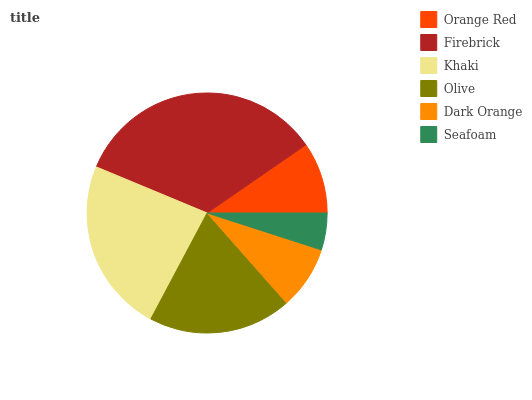Is Seafoam the minimum?
Answer yes or no. Yes. Is Firebrick the maximum?
Answer yes or no. Yes. Is Khaki the minimum?
Answer yes or no. No. Is Khaki the maximum?
Answer yes or no. No. Is Firebrick greater than Khaki?
Answer yes or no. Yes. Is Khaki less than Firebrick?
Answer yes or no. Yes. Is Khaki greater than Firebrick?
Answer yes or no. No. Is Firebrick less than Khaki?
Answer yes or no. No. Is Olive the high median?
Answer yes or no. Yes. Is Orange Red the low median?
Answer yes or no. Yes. Is Dark Orange the high median?
Answer yes or no. No. Is Olive the low median?
Answer yes or no. No. 